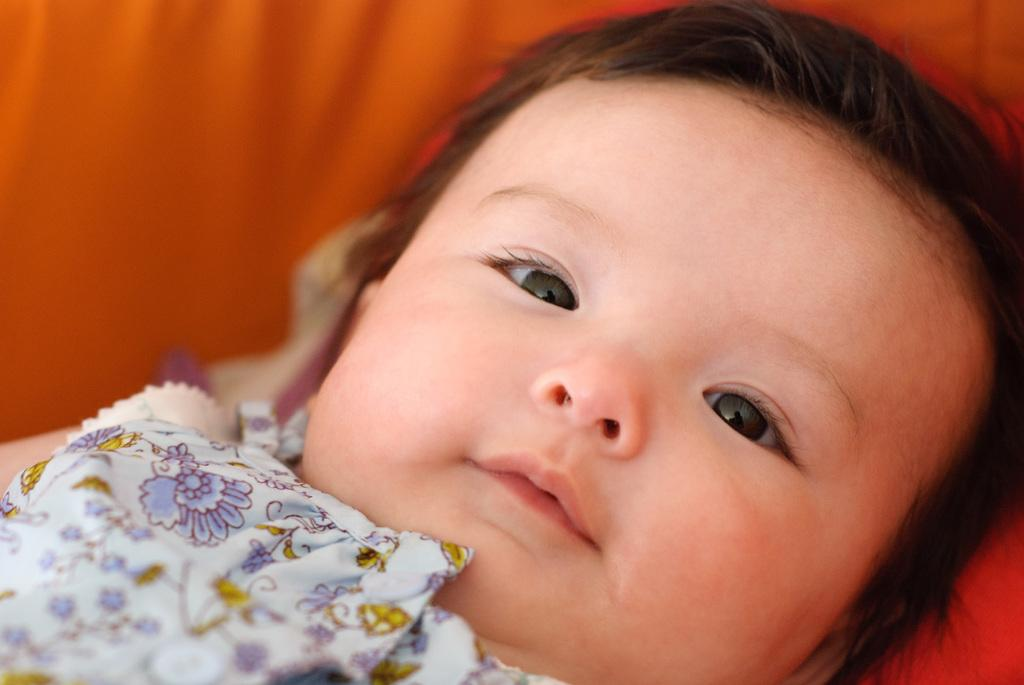What is the main subject of the image? The main subject of the image is a baby. What is the baby resting on or sitting on in the image? The baby is on an orange surface. What type of dinner is the baby eating in the image? There is no dinner present in the image; the baby is simply on an orange surface. What time does the alarm go off in the image? There is no alarm present in the image. 